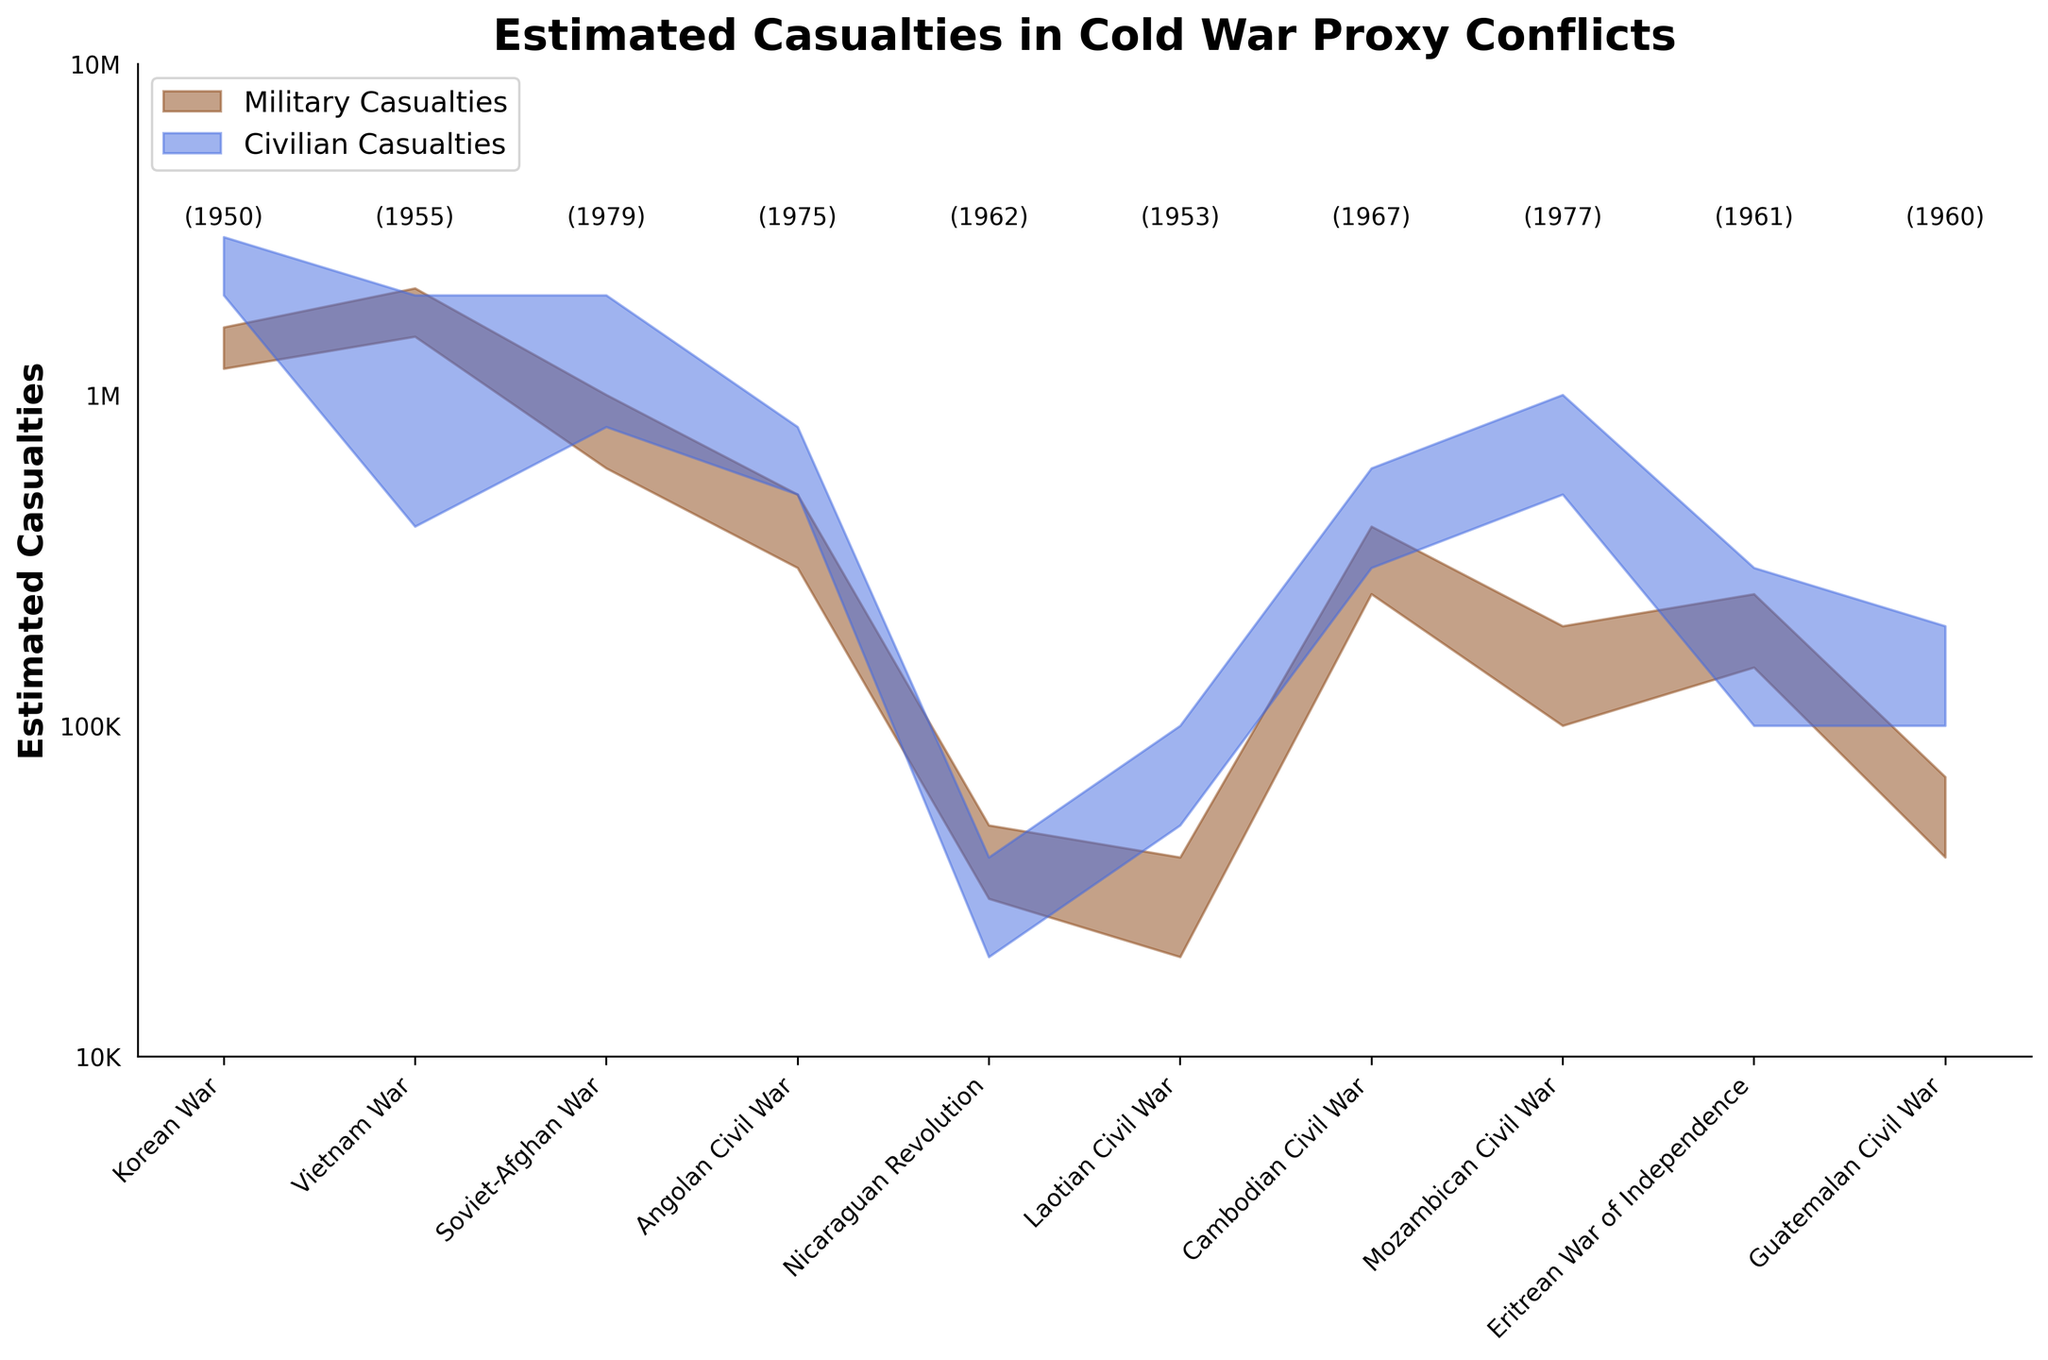What is the title of the figure? The title is usually displayed at the top of the chart in a larger or bolder font to quickly inform viewers of the topic or data being represented. The title of the figure is "Estimated Casualties in Cold War Proxy Conflicts" as indicated by the data and code.
Answer: Estimated Casualties in Cold War Proxy Conflicts What do the brown and blue regions represent in the figure? In the figure, colors are used to differentiate between categories. According to the data and code, the brown region represents military casualties and the blue region represents civilian casualties.
Answer: Military and civilian casualties Which conflict has the highest range of estimated civilian casualties? By inspecting the maximum values at the top of each blue region, the Korean War has the highest range of estimated civilian casualties, from 2,000,000 to 3,000,000.
Answer: Korean War What range of military casualties is estimated for the Angolan Civil War? According to the fan chart, by looking at the brown region corresponding to the Angolan Civil War, the estimated range is from 300,000 to 500,000.
Answer: 300,000 to 500,000 How does the Nicaraguan Revolution compare to the Soviet-Afghan War in terms of estimated civilian casualties? The Nicaraguan Revolution’s civilian casualties are lower, ranging between 20,000 and 40,000, whereas the Soviet-Afghan War ranges from 800,000 to 2,000,000.
Answer: Lower in the Nicaraguan Revolution In what year did the conflict with the highest military casualties end? The figure includes years indicated next to the labels. The Korean War, ending in 1950, has the highest military casualties ranging from 1,200,000 to 1,600,000.
Answer: 1950 Which conflict occurred first chronologically based on the provided data? The Laotian Civil War began in 1953, which is the earliest starting year among the listed conflicts, based on the data point annotations.
Answer: Laotian Civil War What is the total possible range of casualties (both military and civilian) in the Cambodian Civil War? By summing the lower and upper estimates of both military and civilian casualties for the Cambodian Civil War, which are 250,000 and 400,000 (military) and 300,000 and 600,000 (civilian), we get a range from 550,000 to 1,000,000.
Answer: 550,000 to 1,000,000 What can be inferred about the relative impact on civilians versus military personnel in most of these conflicts? By observing the fan chart, the blue areas typically appear larger than the brown areas, indicating that civilian casualties often exceeded military casualties in most of these Cold War proxy conflicts.
Answer: Civilian casualties generally exceeded military casualties 